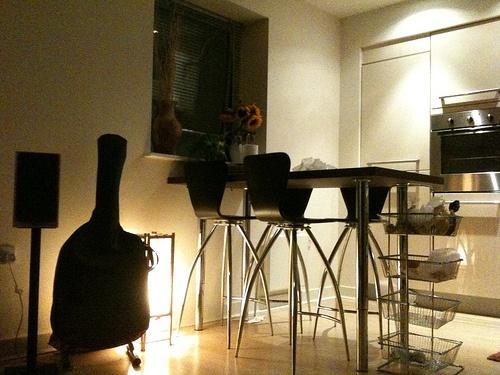Describe the objects in this image and their specific colors. I can see bottle in black, olive, maroon, and white tones, chair in black, beige, and olive tones, oven in black, olive, and gray tones, dining table in black, olive, and tan tones, and chair in black, olive, ivory, and tan tones in this image. 